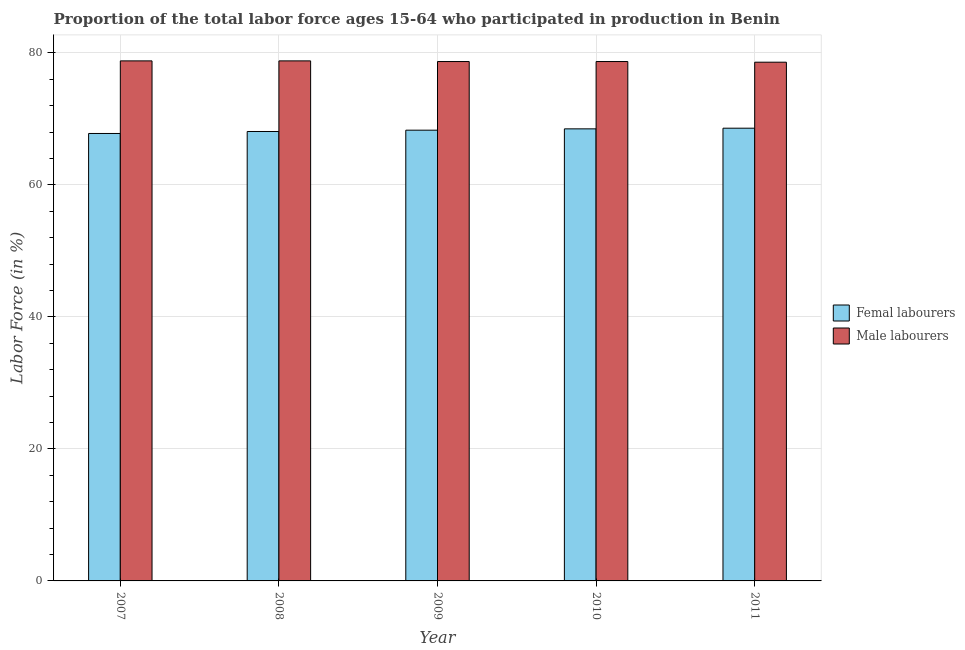How many groups of bars are there?
Make the answer very short. 5. Are the number of bars per tick equal to the number of legend labels?
Give a very brief answer. Yes. What is the label of the 4th group of bars from the left?
Give a very brief answer. 2010. What is the percentage of male labour force in 2009?
Ensure brevity in your answer.  78.7. Across all years, what is the maximum percentage of male labour force?
Your answer should be very brief. 78.8. Across all years, what is the minimum percentage of female labor force?
Your response must be concise. 67.8. In which year was the percentage of female labor force maximum?
Your response must be concise. 2011. In which year was the percentage of male labour force minimum?
Your response must be concise. 2011. What is the total percentage of female labor force in the graph?
Provide a short and direct response. 341.3. What is the difference between the percentage of male labour force in 2009 and that in 2010?
Your answer should be compact. 0. What is the difference between the percentage of male labour force in 2009 and the percentage of female labor force in 2007?
Make the answer very short. -0.1. What is the average percentage of female labor force per year?
Your answer should be compact. 68.26. What is the ratio of the percentage of female labor force in 2007 to that in 2011?
Your answer should be very brief. 0.99. Is the percentage of male labour force in 2010 less than that in 2011?
Give a very brief answer. No. What is the difference between the highest and the lowest percentage of female labor force?
Provide a short and direct response. 0.8. What does the 2nd bar from the left in 2008 represents?
Offer a terse response. Male labourers. What does the 2nd bar from the right in 2007 represents?
Your response must be concise. Femal labourers. Are all the bars in the graph horizontal?
Provide a short and direct response. No. How many years are there in the graph?
Offer a terse response. 5. Does the graph contain any zero values?
Offer a terse response. No. Does the graph contain grids?
Provide a short and direct response. Yes. Where does the legend appear in the graph?
Provide a short and direct response. Center right. How many legend labels are there?
Make the answer very short. 2. How are the legend labels stacked?
Your answer should be compact. Vertical. What is the title of the graph?
Your answer should be very brief. Proportion of the total labor force ages 15-64 who participated in production in Benin. What is the label or title of the Y-axis?
Your answer should be compact. Labor Force (in %). What is the Labor Force (in %) in Femal labourers in 2007?
Offer a terse response. 67.8. What is the Labor Force (in %) of Male labourers in 2007?
Your answer should be compact. 78.8. What is the Labor Force (in %) in Femal labourers in 2008?
Your answer should be very brief. 68.1. What is the Labor Force (in %) of Male labourers in 2008?
Give a very brief answer. 78.8. What is the Labor Force (in %) of Femal labourers in 2009?
Offer a terse response. 68.3. What is the Labor Force (in %) in Male labourers in 2009?
Provide a succinct answer. 78.7. What is the Labor Force (in %) of Femal labourers in 2010?
Offer a terse response. 68.5. What is the Labor Force (in %) in Male labourers in 2010?
Give a very brief answer. 78.7. What is the Labor Force (in %) in Femal labourers in 2011?
Keep it short and to the point. 68.6. What is the Labor Force (in %) in Male labourers in 2011?
Give a very brief answer. 78.6. Across all years, what is the maximum Labor Force (in %) in Femal labourers?
Keep it short and to the point. 68.6. Across all years, what is the maximum Labor Force (in %) of Male labourers?
Ensure brevity in your answer.  78.8. Across all years, what is the minimum Labor Force (in %) of Femal labourers?
Provide a succinct answer. 67.8. Across all years, what is the minimum Labor Force (in %) of Male labourers?
Make the answer very short. 78.6. What is the total Labor Force (in %) of Femal labourers in the graph?
Your answer should be very brief. 341.3. What is the total Labor Force (in %) in Male labourers in the graph?
Keep it short and to the point. 393.6. What is the difference between the Labor Force (in %) in Femal labourers in 2007 and that in 2008?
Offer a very short reply. -0.3. What is the difference between the Labor Force (in %) of Male labourers in 2007 and that in 2008?
Provide a succinct answer. 0. What is the difference between the Labor Force (in %) in Male labourers in 2007 and that in 2009?
Give a very brief answer. 0.1. What is the difference between the Labor Force (in %) in Male labourers in 2007 and that in 2011?
Ensure brevity in your answer.  0.2. What is the difference between the Labor Force (in %) in Male labourers in 2008 and that in 2009?
Your answer should be very brief. 0.1. What is the difference between the Labor Force (in %) in Male labourers in 2008 and that in 2010?
Ensure brevity in your answer.  0.1. What is the difference between the Labor Force (in %) of Male labourers in 2008 and that in 2011?
Your answer should be very brief. 0.2. What is the difference between the Labor Force (in %) in Femal labourers in 2009 and that in 2010?
Make the answer very short. -0.2. What is the difference between the Labor Force (in %) in Male labourers in 2009 and that in 2010?
Keep it short and to the point. 0. What is the difference between the Labor Force (in %) of Femal labourers in 2009 and that in 2011?
Your answer should be very brief. -0.3. What is the difference between the Labor Force (in %) of Male labourers in 2009 and that in 2011?
Offer a very short reply. 0.1. What is the difference between the Labor Force (in %) in Femal labourers in 2010 and that in 2011?
Give a very brief answer. -0.1. What is the difference between the Labor Force (in %) of Femal labourers in 2007 and the Labor Force (in %) of Male labourers in 2008?
Offer a terse response. -11. What is the difference between the Labor Force (in %) in Femal labourers in 2007 and the Labor Force (in %) in Male labourers in 2010?
Offer a terse response. -10.9. What is the difference between the Labor Force (in %) of Femal labourers in 2008 and the Labor Force (in %) of Male labourers in 2009?
Your response must be concise. -10.6. What is the difference between the Labor Force (in %) of Femal labourers in 2009 and the Labor Force (in %) of Male labourers in 2011?
Offer a very short reply. -10.3. What is the average Labor Force (in %) of Femal labourers per year?
Make the answer very short. 68.26. What is the average Labor Force (in %) in Male labourers per year?
Provide a short and direct response. 78.72. In the year 2008, what is the difference between the Labor Force (in %) of Femal labourers and Labor Force (in %) of Male labourers?
Your answer should be very brief. -10.7. What is the ratio of the Labor Force (in %) of Male labourers in 2007 to that in 2008?
Offer a very short reply. 1. What is the ratio of the Labor Force (in %) in Femal labourers in 2007 to that in 2010?
Offer a terse response. 0.99. What is the ratio of the Labor Force (in %) of Femal labourers in 2007 to that in 2011?
Keep it short and to the point. 0.99. What is the ratio of the Labor Force (in %) in Male labourers in 2007 to that in 2011?
Your answer should be compact. 1. What is the ratio of the Labor Force (in %) of Femal labourers in 2008 to that in 2009?
Provide a succinct answer. 1. What is the ratio of the Labor Force (in %) of Femal labourers in 2008 to that in 2010?
Your answer should be compact. 0.99. What is the ratio of the Labor Force (in %) in Male labourers in 2008 to that in 2010?
Give a very brief answer. 1. What is the ratio of the Labor Force (in %) in Femal labourers in 2008 to that in 2011?
Your answer should be very brief. 0.99. What is the ratio of the Labor Force (in %) in Femal labourers in 2009 to that in 2010?
Provide a short and direct response. 1. What is the ratio of the Labor Force (in %) of Male labourers in 2009 to that in 2010?
Your answer should be compact. 1. What is the ratio of the Labor Force (in %) of Male labourers in 2009 to that in 2011?
Provide a short and direct response. 1. What is the ratio of the Labor Force (in %) of Femal labourers in 2010 to that in 2011?
Provide a short and direct response. 1. What is the difference between the highest and the second highest Labor Force (in %) in Male labourers?
Give a very brief answer. 0. What is the difference between the highest and the lowest Labor Force (in %) in Male labourers?
Ensure brevity in your answer.  0.2. 